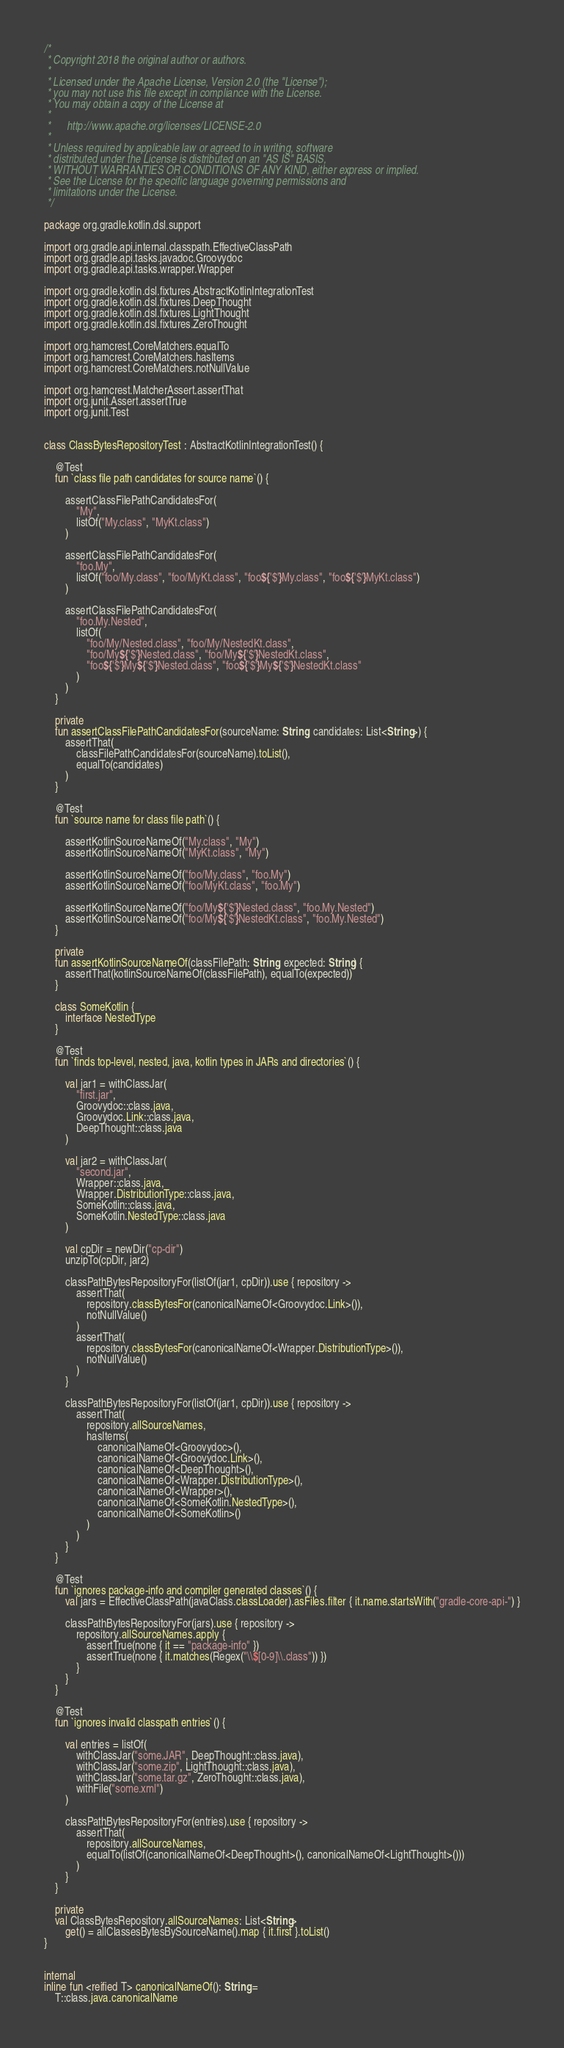<code> <loc_0><loc_0><loc_500><loc_500><_Kotlin_>/*
 * Copyright 2018 the original author or authors.
 *
 * Licensed under the Apache License, Version 2.0 (the "License");
 * you may not use this file except in compliance with the License.
 * You may obtain a copy of the License at
 *
 *      http://www.apache.org/licenses/LICENSE-2.0
 *
 * Unless required by applicable law or agreed to in writing, software
 * distributed under the License is distributed on an "AS IS" BASIS,
 * WITHOUT WARRANTIES OR CONDITIONS OF ANY KIND, either express or implied.
 * See the License for the specific language governing permissions and
 * limitations under the License.
 */

package org.gradle.kotlin.dsl.support

import org.gradle.api.internal.classpath.EffectiveClassPath
import org.gradle.api.tasks.javadoc.Groovydoc
import org.gradle.api.tasks.wrapper.Wrapper

import org.gradle.kotlin.dsl.fixtures.AbstractKotlinIntegrationTest
import org.gradle.kotlin.dsl.fixtures.DeepThought
import org.gradle.kotlin.dsl.fixtures.LightThought
import org.gradle.kotlin.dsl.fixtures.ZeroThought

import org.hamcrest.CoreMatchers.equalTo
import org.hamcrest.CoreMatchers.hasItems
import org.hamcrest.CoreMatchers.notNullValue

import org.hamcrest.MatcherAssert.assertThat
import org.junit.Assert.assertTrue
import org.junit.Test


class ClassBytesRepositoryTest : AbstractKotlinIntegrationTest() {

    @Test
    fun `class file path candidates for source name`() {

        assertClassFilePathCandidatesFor(
            "My",
            listOf("My.class", "MyKt.class")
        )

        assertClassFilePathCandidatesFor(
            "foo.My",
            listOf("foo/My.class", "foo/MyKt.class", "foo${'$'}My.class", "foo${'$'}MyKt.class")
        )

        assertClassFilePathCandidatesFor(
            "foo.My.Nested",
            listOf(
                "foo/My/Nested.class", "foo/My/NestedKt.class",
                "foo/My${'$'}Nested.class", "foo/My${'$'}NestedKt.class",
                "foo${'$'}My${'$'}Nested.class", "foo${'$'}My${'$'}NestedKt.class"
            )
        )
    }

    private
    fun assertClassFilePathCandidatesFor(sourceName: String, candidates: List<String>) {
        assertThat(
            classFilePathCandidatesFor(sourceName).toList(),
            equalTo(candidates)
        )
    }

    @Test
    fun `source name for class file path`() {

        assertKotlinSourceNameOf("My.class", "My")
        assertKotlinSourceNameOf("MyKt.class", "My")

        assertKotlinSourceNameOf("foo/My.class", "foo.My")
        assertKotlinSourceNameOf("foo/MyKt.class", "foo.My")

        assertKotlinSourceNameOf("foo/My${'$'}Nested.class", "foo.My.Nested")
        assertKotlinSourceNameOf("foo/My${'$'}NestedKt.class", "foo.My.Nested")
    }

    private
    fun assertKotlinSourceNameOf(classFilePath: String, expected: String) {
        assertThat(kotlinSourceNameOf(classFilePath), equalTo(expected))
    }

    class SomeKotlin {
        interface NestedType
    }

    @Test
    fun `finds top-level, nested, java, kotlin types in JARs and directories`() {

        val jar1 = withClassJar(
            "first.jar",
            Groovydoc::class.java,
            Groovydoc.Link::class.java,
            DeepThought::class.java
        )

        val jar2 = withClassJar(
            "second.jar",
            Wrapper::class.java,
            Wrapper.DistributionType::class.java,
            SomeKotlin::class.java,
            SomeKotlin.NestedType::class.java
        )

        val cpDir = newDir("cp-dir")
        unzipTo(cpDir, jar2)

        classPathBytesRepositoryFor(listOf(jar1, cpDir)).use { repository ->
            assertThat(
                repository.classBytesFor(canonicalNameOf<Groovydoc.Link>()),
                notNullValue()
            )
            assertThat(
                repository.classBytesFor(canonicalNameOf<Wrapper.DistributionType>()),
                notNullValue()
            )
        }

        classPathBytesRepositoryFor(listOf(jar1, cpDir)).use { repository ->
            assertThat(
                repository.allSourceNames,
                hasItems(
                    canonicalNameOf<Groovydoc>(),
                    canonicalNameOf<Groovydoc.Link>(),
                    canonicalNameOf<DeepThought>(),
                    canonicalNameOf<Wrapper.DistributionType>(),
                    canonicalNameOf<Wrapper>(),
                    canonicalNameOf<SomeKotlin.NestedType>(),
                    canonicalNameOf<SomeKotlin>()
                )
            )
        }
    }

    @Test
    fun `ignores package-info and compiler generated classes`() {
        val jars = EffectiveClassPath(javaClass.classLoader).asFiles.filter { it.name.startsWith("gradle-core-api-") }

        classPathBytesRepositoryFor(jars).use { repository ->
            repository.allSourceNames.apply {
                assertTrue(none { it == "package-info" })
                assertTrue(none { it.matches(Regex("\\$[0-9]\\.class")) })
            }
        }
    }

    @Test
    fun `ignores invalid classpath entries`() {

        val entries = listOf(
            withClassJar("some.JAR", DeepThought::class.java),
            withClassJar("some.zip", LightThought::class.java),
            withClassJar("some.tar.gz", ZeroThought::class.java),
            withFile("some.xml")
        )

        classPathBytesRepositoryFor(entries).use { repository ->
            assertThat(
                repository.allSourceNames,
                equalTo(listOf(canonicalNameOf<DeepThought>(), canonicalNameOf<LightThought>()))
            )
        }
    }

    private
    val ClassBytesRepository.allSourceNames: List<String>
        get() = allClassesBytesBySourceName().map { it.first }.toList()
}


internal
inline fun <reified T> canonicalNameOf(): String =
    T::class.java.canonicalName
</code> 